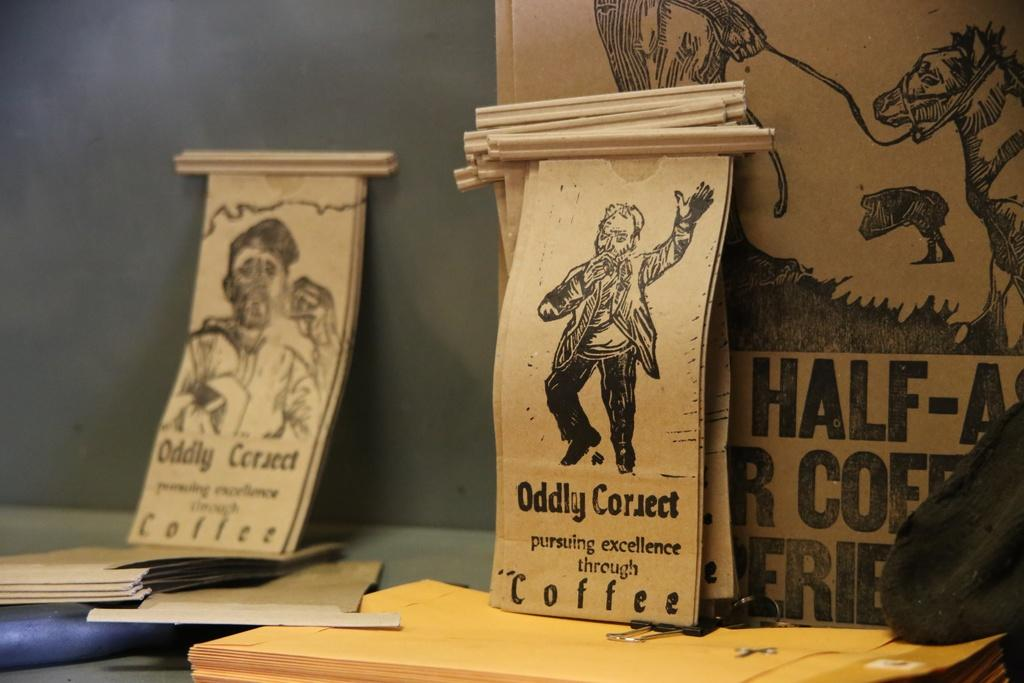<image>
Share a concise interpretation of the image provided. small pictures of ODDLY correct that says 'pursuing excellence through coffee' 